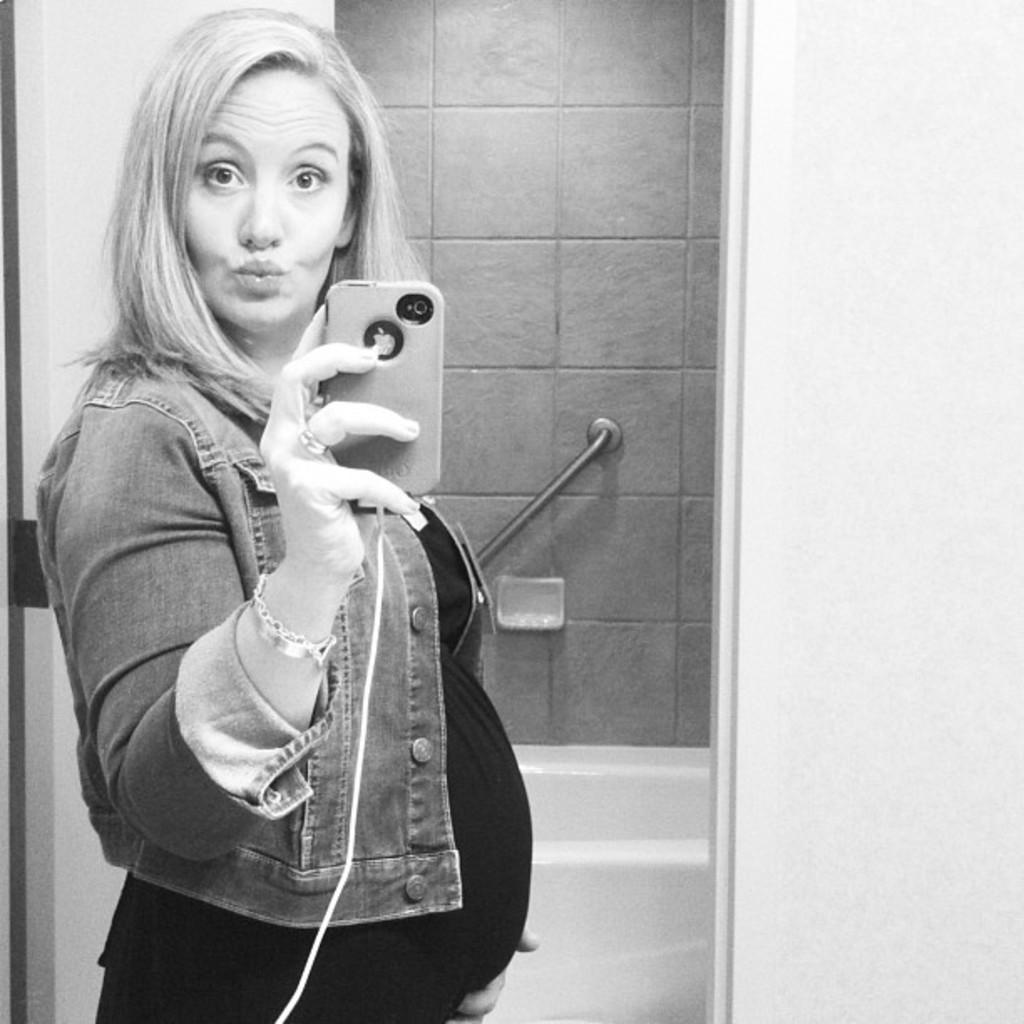Who is present in the image? There is a woman in the image. What is the woman doing in the image? The woman is standing in the image. What object is the woman holding in her hand? The woman is holding a mobile in her hand. What can be seen in the background of the image? There is a bathtub in the image. What feature is present for support or assistance in the image? There is a handle to hold in the image. What architectural element is visible in the image? There is a door in the image. What is the judge's reaction to the end of the trial in the image? There is no judge or trial present in the image; it features a woman standing with a mobile in her hand, a bathtub in the background, a handle to hold, and a door. 